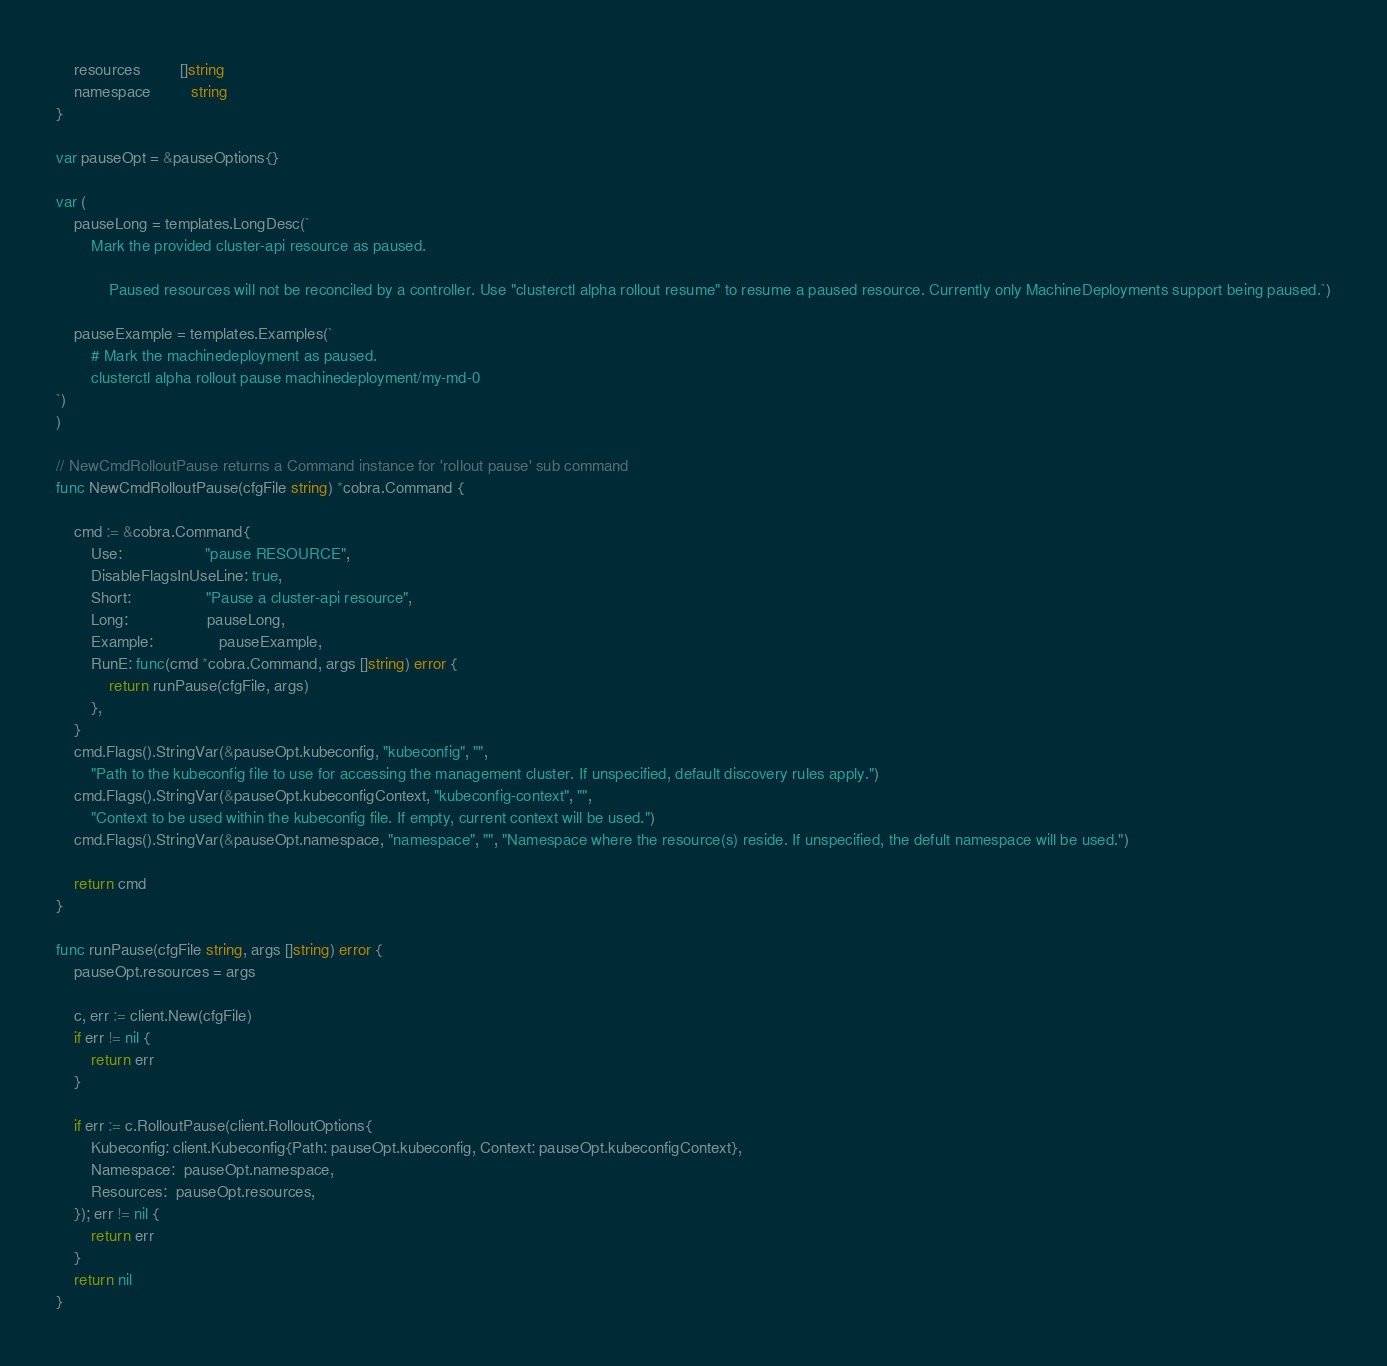<code> <loc_0><loc_0><loc_500><loc_500><_Go_>	resources         []string
	namespace         string
}

var pauseOpt = &pauseOptions{}

var (
	pauseLong = templates.LongDesc(`
		Mark the provided cluster-api resource as paused.

	        Paused resources will not be reconciled by a controller. Use "clusterctl alpha rollout resume" to resume a paused resource. Currently only MachineDeployments support being paused.`)

	pauseExample = templates.Examples(`
		# Mark the machinedeployment as paused.
		clusterctl alpha rollout pause machinedeployment/my-md-0
`)
)

// NewCmdRolloutPause returns a Command instance for 'rollout pause' sub command
func NewCmdRolloutPause(cfgFile string) *cobra.Command {

	cmd := &cobra.Command{
		Use:                   "pause RESOURCE",
		DisableFlagsInUseLine: true,
		Short:                 "Pause a cluster-api resource",
		Long:                  pauseLong,
		Example:               pauseExample,
		RunE: func(cmd *cobra.Command, args []string) error {
			return runPause(cfgFile, args)
		},
	}
	cmd.Flags().StringVar(&pauseOpt.kubeconfig, "kubeconfig", "",
		"Path to the kubeconfig file to use for accessing the management cluster. If unspecified, default discovery rules apply.")
	cmd.Flags().StringVar(&pauseOpt.kubeconfigContext, "kubeconfig-context", "",
		"Context to be used within the kubeconfig file. If empty, current context will be used.")
	cmd.Flags().StringVar(&pauseOpt.namespace, "namespace", "", "Namespace where the resource(s) reside. If unspecified, the defult namespace will be used.")

	return cmd
}

func runPause(cfgFile string, args []string) error {
	pauseOpt.resources = args

	c, err := client.New(cfgFile)
	if err != nil {
		return err
	}

	if err := c.RolloutPause(client.RolloutOptions{
		Kubeconfig: client.Kubeconfig{Path: pauseOpt.kubeconfig, Context: pauseOpt.kubeconfigContext},
		Namespace:  pauseOpt.namespace,
		Resources:  pauseOpt.resources,
	}); err != nil {
		return err
	}
	return nil
}
</code> 